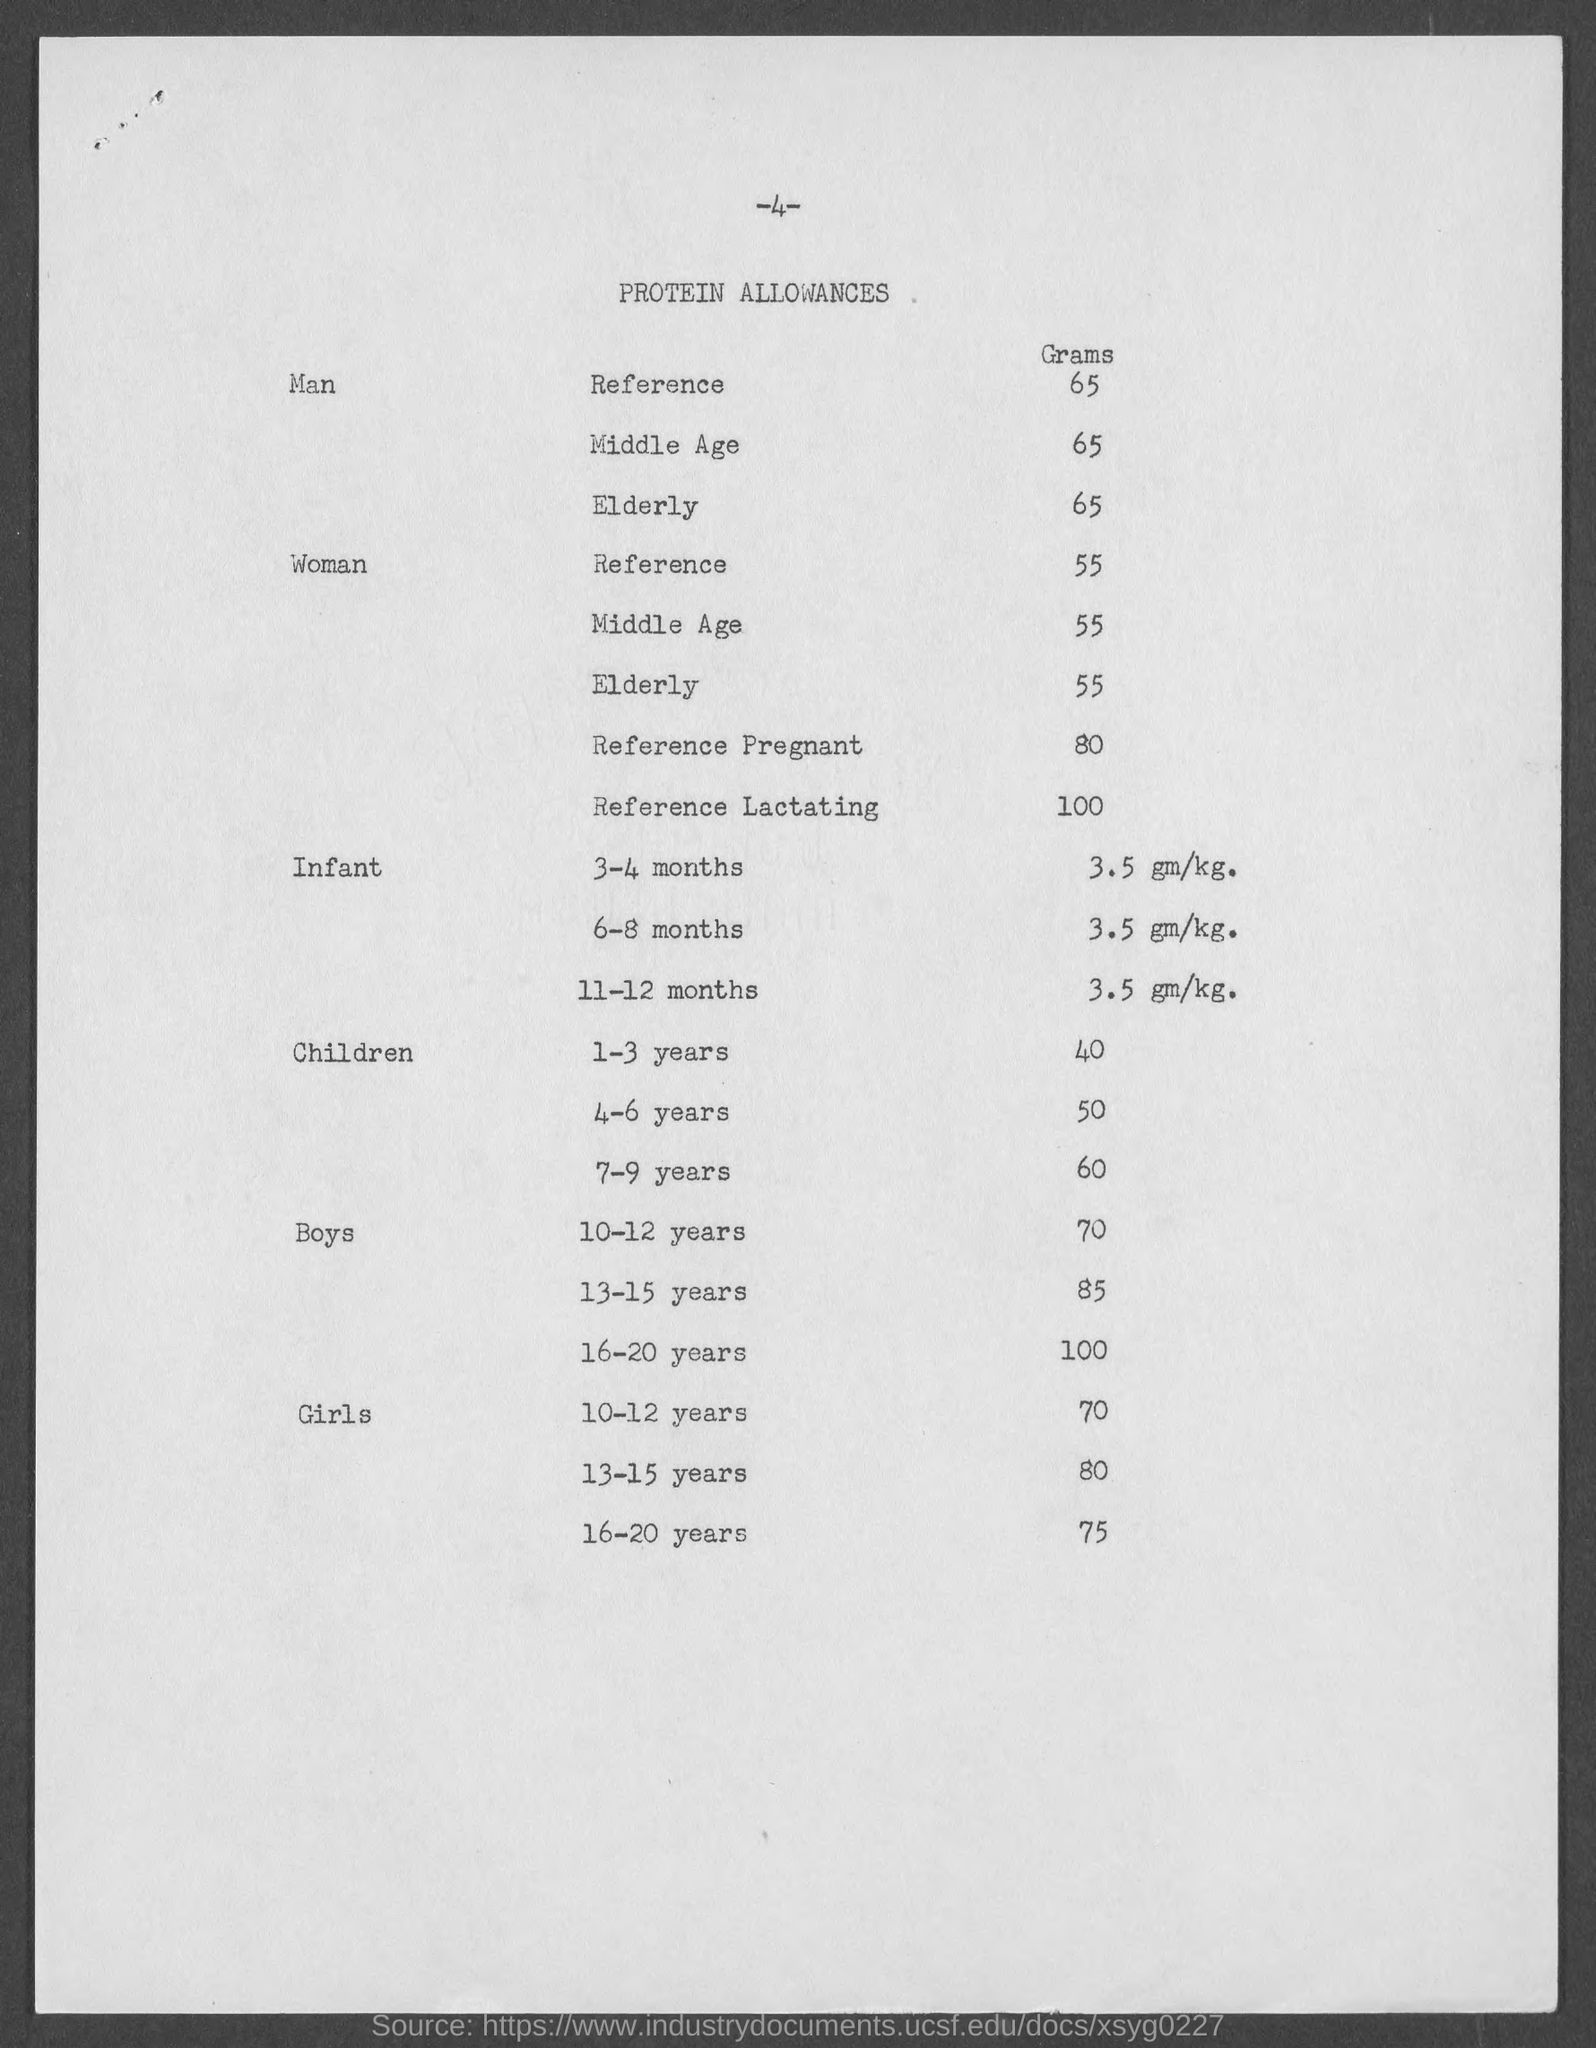What is the page number at top of the page?
Make the answer very short. 4. What is the heading of the page ?
Make the answer very short. Protein allowances. 